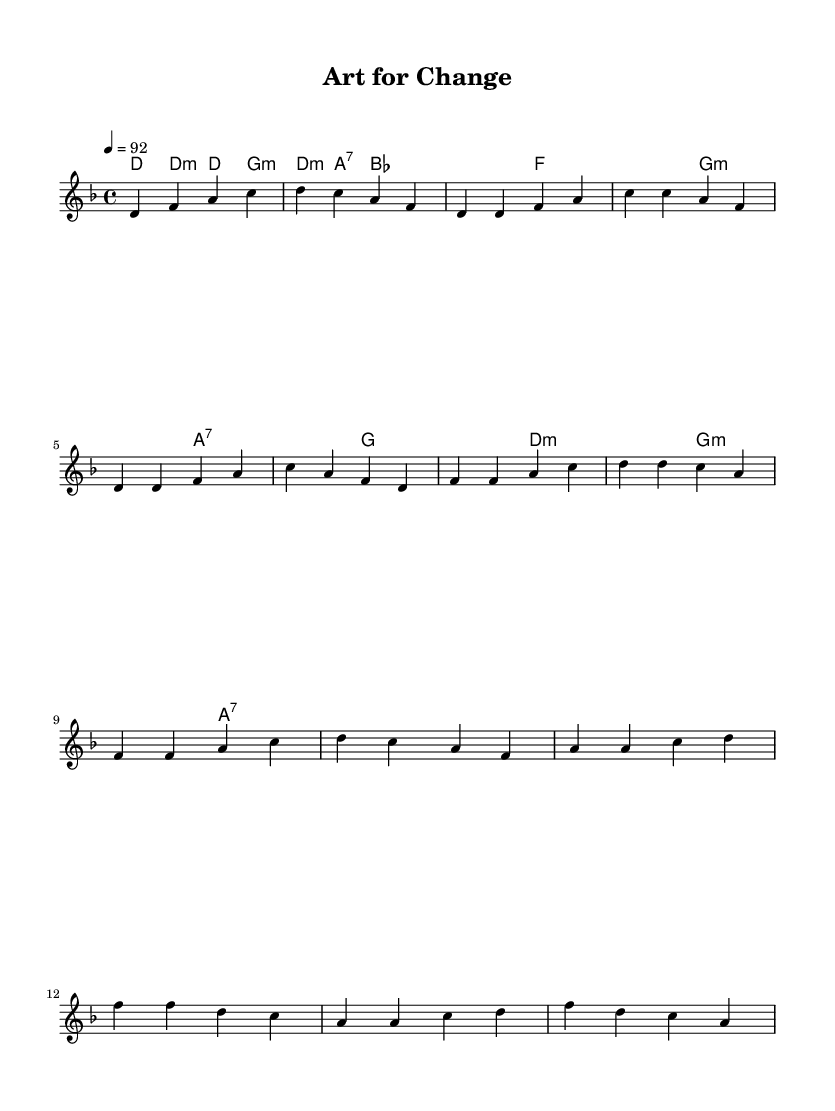What is the key signature of this music? The key signature is indicated at the beginning of the score. In this case, it is D minor, which has one flat (B♭).
Answer: D minor What is the time signature of the piece? The time signature appears at the beginning of the score, noted as 4/4, which means there are four beats per measure.
Answer: 4/4 What is the tempo marking for the music? The tempo marking is found at the beginning of the score, specifying the speed. Here it indicates a tempo of 92 beats per minute.
Answer: 92 How many sections are there in the song structure? By analyzing the melodic and harmonic sections, we identify an Intro, a Verse, a Chorus, and a Bridge, totaling four sections.
Answer: Four Which chord is used at the beginning of the verse? The first chord of the verse can be found by looking at the harmonies section. The first chord listed after the intro is D minor (d:m1).
Answer: D minor What type of musical genre does this piece represent? The style and structure, including the rap motivational theme, indicate that this piece falls under the category of rap music, particularly focused on social change.
Answer: Rap 